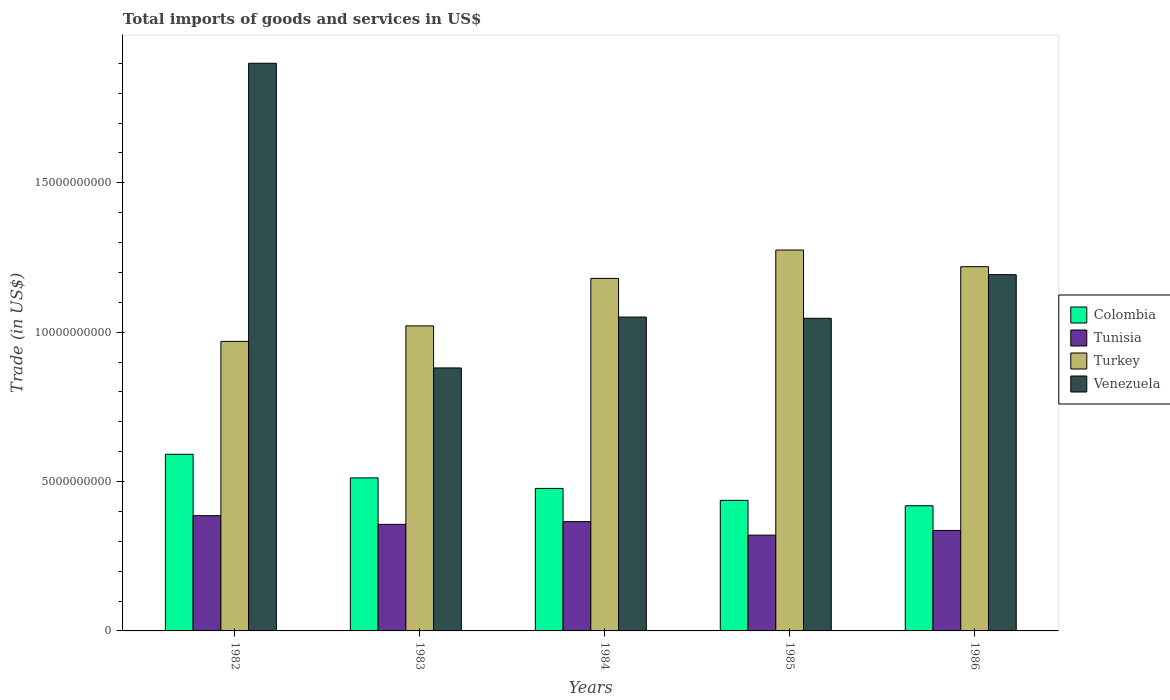How many groups of bars are there?
Your answer should be very brief. 5. Are the number of bars per tick equal to the number of legend labels?
Make the answer very short. Yes. Are the number of bars on each tick of the X-axis equal?
Make the answer very short. Yes. How many bars are there on the 5th tick from the left?
Offer a very short reply. 4. What is the total imports of goods and services in Colombia in 1984?
Provide a succinct answer. 4.77e+09. Across all years, what is the maximum total imports of goods and services in Venezuela?
Give a very brief answer. 1.90e+1. Across all years, what is the minimum total imports of goods and services in Colombia?
Your response must be concise. 4.19e+09. In which year was the total imports of goods and services in Tunisia maximum?
Make the answer very short. 1982. In which year was the total imports of goods and services in Colombia minimum?
Your response must be concise. 1986. What is the total total imports of goods and services in Turkey in the graph?
Ensure brevity in your answer.  5.67e+1. What is the difference between the total imports of goods and services in Venezuela in 1985 and that in 1986?
Your answer should be very brief. -1.46e+09. What is the difference between the total imports of goods and services in Turkey in 1985 and the total imports of goods and services in Colombia in 1984?
Offer a very short reply. 7.98e+09. What is the average total imports of goods and services in Tunisia per year?
Ensure brevity in your answer.  3.53e+09. In the year 1983, what is the difference between the total imports of goods and services in Venezuela and total imports of goods and services in Turkey?
Your answer should be compact. -1.41e+09. What is the ratio of the total imports of goods and services in Venezuela in 1982 to that in 1983?
Your answer should be compact. 2.16. Is the total imports of goods and services in Turkey in 1984 less than that in 1986?
Your response must be concise. Yes. Is the difference between the total imports of goods and services in Venezuela in 1982 and 1985 greater than the difference between the total imports of goods and services in Turkey in 1982 and 1985?
Your answer should be compact. Yes. What is the difference between the highest and the second highest total imports of goods and services in Turkey?
Keep it short and to the point. 5.58e+08. What is the difference between the highest and the lowest total imports of goods and services in Colombia?
Your answer should be very brief. 1.72e+09. Is the sum of the total imports of goods and services in Venezuela in 1983 and 1985 greater than the maximum total imports of goods and services in Colombia across all years?
Make the answer very short. Yes. Is it the case that in every year, the sum of the total imports of goods and services in Venezuela and total imports of goods and services in Tunisia is greater than the sum of total imports of goods and services in Colombia and total imports of goods and services in Turkey?
Make the answer very short. No. How many bars are there?
Your response must be concise. 20. Are all the bars in the graph horizontal?
Offer a terse response. No. How many years are there in the graph?
Give a very brief answer. 5. Are the values on the major ticks of Y-axis written in scientific E-notation?
Offer a very short reply. No. Does the graph contain any zero values?
Keep it short and to the point. No. Does the graph contain grids?
Your response must be concise. No. How many legend labels are there?
Ensure brevity in your answer.  4. How are the legend labels stacked?
Offer a very short reply. Vertical. What is the title of the graph?
Offer a very short reply. Total imports of goods and services in US$. Does "Latin America(all income levels)" appear as one of the legend labels in the graph?
Offer a terse response. No. What is the label or title of the Y-axis?
Give a very brief answer. Trade (in US$). What is the Trade (in US$) in Colombia in 1982?
Your answer should be very brief. 5.91e+09. What is the Trade (in US$) in Tunisia in 1982?
Offer a terse response. 3.86e+09. What is the Trade (in US$) in Turkey in 1982?
Offer a terse response. 9.69e+09. What is the Trade (in US$) in Venezuela in 1982?
Offer a terse response. 1.90e+1. What is the Trade (in US$) of Colombia in 1983?
Keep it short and to the point. 5.12e+09. What is the Trade (in US$) in Tunisia in 1983?
Make the answer very short. 3.57e+09. What is the Trade (in US$) in Turkey in 1983?
Offer a very short reply. 1.02e+1. What is the Trade (in US$) of Venezuela in 1983?
Provide a short and direct response. 8.80e+09. What is the Trade (in US$) of Colombia in 1984?
Offer a terse response. 4.77e+09. What is the Trade (in US$) of Tunisia in 1984?
Give a very brief answer. 3.66e+09. What is the Trade (in US$) in Turkey in 1984?
Provide a short and direct response. 1.18e+1. What is the Trade (in US$) of Venezuela in 1984?
Offer a very short reply. 1.05e+1. What is the Trade (in US$) of Colombia in 1985?
Your answer should be very brief. 4.37e+09. What is the Trade (in US$) in Tunisia in 1985?
Your response must be concise. 3.21e+09. What is the Trade (in US$) of Turkey in 1985?
Make the answer very short. 1.28e+1. What is the Trade (in US$) of Venezuela in 1985?
Ensure brevity in your answer.  1.05e+1. What is the Trade (in US$) in Colombia in 1986?
Provide a short and direct response. 4.19e+09. What is the Trade (in US$) in Tunisia in 1986?
Provide a short and direct response. 3.36e+09. What is the Trade (in US$) in Turkey in 1986?
Provide a short and direct response. 1.22e+1. What is the Trade (in US$) in Venezuela in 1986?
Provide a succinct answer. 1.19e+1. Across all years, what is the maximum Trade (in US$) in Colombia?
Make the answer very short. 5.91e+09. Across all years, what is the maximum Trade (in US$) in Tunisia?
Keep it short and to the point. 3.86e+09. Across all years, what is the maximum Trade (in US$) of Turkey?
Offer a very short reply. 1.28e+1. Across all years, what is the maximum Trade (in US$) of Venezuela?
Ensure brevity in your answer.  1.90e+1. Across all years, what is the minimum Trade (in US$) in Colombia?
Give a very brief answer. 4.19e+09. Across all years, what is the minimum Trade (in US$) in Tunisia?
Ensure brevity in your answer.  3.21e+09. Across all years, what is the minimum Trade (in US$) of Turkey?
Make the answer very short. 9.69e+09. Across all years, what is the minimum Trade (in US$) of Venezuela?
Offer a terse response. 8.80e+09. What is the total Trade (in US$) in Colombia in the graph?
Ensure brevity in your answer.  2.44e+1. What is the total Trade (in US$) in Tunisia in the graph?
Provide a succinct answer. 1.77e+1. What is the total Trade (in US$) of Turkey in the graph?
Your answer should be compact. 5.67e+1. What is the total Trade (in US$) of Venezuela in the graph?
Your response must be concise. 6.07e+1. What is the difference between the Trade (in US$) in Colombia in 1982 and that in 1983?
Provide a short and direct response. 7.91e+08. What is the difference between the Trade (in US$) of Tunisia in 1982 and that in 1983?
Provide a short and direct response. 2.91e+08. What is the difference between the Trade (in US$) of Turkey in 1982 and that in 1983?
Give a very brief answer. -5.20e+08. What is the difference between the Trade (in US$) of Venezuela in 1982 and that in 1983?
Provide a succinct answer. 1.02e+1. What is the difference between the Trade (in US$) in Colombia in 1982 and that in 1984?
Ensure brevity in your answer.  1.14e+09. What is the difference between the Trade (in US$) in Tunisia in 1982 and that in 1984?
Keep it short and to the point. 1.99e+08. What is the difference between the Trade (in US$) of Turkey in 1982 and that in 1984?
Make the answer very short. -2.11e+09. What is the difference between the Trade (in US$) in Venezuela in 1982 and that in 1984?
Give a very brief answer. 8.50e+09. What is the difference between the Trade (in US$) in Colombia in 1982 and that in 1985?
Provide a succinct answer. 1.54e+09. What is the difference between the Trade (in US$) of Tunisia in 1982 and that in 1985?
Offer a terse response. 6.51e+08. What is the difference between the Trade (in US$) of Turkey in 1982 and that in 1985?
Your response must be concise. -3.06e+09. What is the difference between the Trade (in US$) of Venezuela in 1982 and that in 1985?
Make the answer very short. 8.54e+09. What is the difference between the Trade (in US$) of Colombia in 1982 and that in 1986?
Give a very brief answer. 1.72e+09. What is the difference between the Trade (in US$) in Tunisia in 1982 and that in 1986?
Provide a succinct answer. 4.95e+08. What is the difference between the Trade (in US$) in Turkey in 1982 and that in 1986?
Provide a short and direct response. -2.50e+09. What is the difference between the Trade (in US$) in Venezuela in 1982 and that in 1986?
Ensure brevity in your answer.  7.08e+09. What is the difference between the Trade (in US$) of Colombia in 1983 and that in 1984?
Offer a very short reply. 3.52e+08. What is the difference between the Trade (in US$) in Tunisia in 1983 and that in 1984?
Give a very brief answer. -9.18e+07. What is the difference between the Trade (in US$) of Turkey in 1983 and that in 1984?
Offer a very short reply. -1.59e+09. What is the difference between the Trade (in US$) of Venezuela in 1983 and that in 1984?
Provide a short and direct response. -1.70e+09. What is the difference between the Trade (in US$) in Colombia in 1983 and that in 1985?
Offer a terse response. 7.52e+08. What is the difference between the Trade (in US$) of Tunisia in 1983 and that in 1985?
Offer a terse response. 3.60e+08. What is the difference between the Trade (in US$) in Turkey in 1983 and that in 1985?
Give a very brief answer. -2.54e+09. What is the difference between the Trade (in US$) in Venezuela in 1983 and that in 1985?
Ensure brevity in your answer.  -1.66e+09. What is the difference between the Trade (in US$) of Colombia in 1983 and that in 1986?
Offer a terse response. 9.32e+08. What is the difference between the Trade (in US$) of Tunisia in 1983 and that in 1986?
Your response must be concise. 2.03e+08. What is the difference between the Trade (in US$) in Turkey in 1983 and that in 1986?
Provide a succinct answer. -1.98e+09. What is the difference between the Trade (in US$) in Venezuela in 1983 and that in 1986?
Your answer should be compact. -3.12e+09. What is the difference between the Trade (in US$) of Colombia in 1984 and that in 1985?
Provide a short and direct response. 4.00e+08. What is the difference between the Trade (in US$) in Tunisia in 1984 and that in 1985?
Offer a very short reply. 4.52e+08. What is the difference between the Trade (in US$) in Turkey in 1984 and that in 1985?
Your answer should be very brief. -9.50e+08. What is the difference between the Trade (in US$) in Venezuela in 1984 and that in 1985?
Provide a short and direct response. 4.04e+07. What is the difference between the Trade (in US$) of Colombia in 1984 and that in 1986?
Make the answer very short. 5.80e+08. What is the difference between the Trade (in US$) of Tunisia in 1984 and that in 1986?
Provide a short and direct response. 2.95e+08. What is the difference between the Trade (in US$) in Turkey in 1984 and that in 1986?
Give a very brief answer. -3.92e+08. What is the difference between the Trade (in US$) in Venezuela in 1984 and that in 1986?
Provide a succinct answer. -1.42e+09. What is the difference between the Trade (in US$) of Colombia in 1985 and that in 1986?
Make the answer very short. 1.80e+08. What is the difference between the Trade (in US$) of Tunisia in 1985 and that in 1986?
Your answer should be very brief. -1.57e+08. What is the difference between the Trade (in US$) of Turkey in 1985 and that in 1986?
Provide a succinct answer. 5.58e+08. What is the difference between the Trade (in US$) of Venezuela in 1985 and that in 1986?
Ensure brevity in your answer.  -1.46e+09. What is the difference between the Trade (in US$) in Colombia in 1982 and the Trade (in US$) in Tunisia in 1983?
Your response must be concise. 2.35e+09. What is the difference between the Trade (in US$) of Colombia in 1982 and the Trade (in US$) of Turkey in 1983?
Offer a terse response. -4.30e+09. What is the difference between the Trade (in US$) of Colombia in 1982 and the Trade (in US$) of Venezuela in 1983?
Your answer should be very brief. -2.89e+09. What is the difference between the Trade (in US$) in Tunisia in 1982 and the Trade (in US$) in Turkey in 1983?
Ensure brevity in your answer.  -6.35e+09. What is the difference between the Trade (in US$) in Tunisia in 1982 and the Trade (in US$) in Venezuela in 1983?
Keep it short and to the point. -4.95e+09. What is the difference between the Trade (in US$) in Turkey in 1982 and the Trade (in US$) in Venezuela in 1983?
Your answer should be very brief. 8.88e+08. What is the difference between the Trade (in US$) of Colombia in 1982 and the Trade (in US$) of Tunisia in 1984?
Offer a very short reply. 2.25e+09. What is the difference between the Trade (in US$) of Colombia in 1982 and the Trade (in US$) of Turkey in 1984?
Offer a very short reply. -5.89e+09. What is the difference between the Trade (in US$) in Colombia in 1982 and the Trade (in US$) in Venezuela in 1984?
Give a very brief answer. -4.59e+09. What is the difference between the Trade (in US$) in Tunisia in 1982 and the Trade (in US$) in Turkey in 1984?
Keep it short and to the point. -7.94e+09. What is the difference between the Trade (in US$) of Tunisia in 1982 and the Trade (in US$) of Venezuela in 1984?
Make the answer very short. -6.65e+09. What is the difference between the Trade (in US$) in Turkey in 1982 and the Trade (in US$) in Venezuela in 1984?
Offer a very short reply. -8.14e+08. What is the difference between the Trade (in US$) in Colombia in 1982 and the Trade (in US$) in Tunisia in 1985?
Ensure brevity in your answer.  2.71e+09. What is the difference between the Trade (in US$) in Colombia in 1982 and the Trade (in US$) in Turkey in 1985?
Provide a succinct answer. -6.84e+09. What is the difference between the Trade (in US$) in Colombia in 1982 and the Trade (in US$) in Venezuela in 1985?
Ensure brevity in your answer.  -4.55e+09. What is the difference between the Trade (in US$) in Tunisia in 1982 and the Trade (in US$) in Turkey in 1985?
Give a very brief answer. -8.89e+09. What is the difference between the Trade (in US$) of Tunisia in 1982 and the Trade (in US$) of Venezuela in 1985?
Offer a very short reply. -6.61e+09. What is the difference between the Trade (in US$) in Turkey in 1982 and the Trade (in US$) in Venezuela in 1985?
Make the answer very short. -7.74e+08. What is the difference between the Trade (in US$) in Colombia in 1982 and the Trade (in US$) in Tunisia in 1986?
Make the answer very short. 2.55e+09. What is the difference between the Trade (in US$) in Colombia in 1982 and the Trade (in US$) in Turkey in 1986?
Offer a terse response. -6.28e+09. What is the difference between the Trade (in US$) of Colombia in 1982 and the Trade (in US$) of Venezuela in 1986?
Your answer should be compact. -6.01e+09. What is the difference between the Trade (in US$) in Tunisia in 1982 and the Trade (in US$) in Turkey in 1986?
Your response must be concise. -8.34e+09. What is the difference between the Trade (in US$) in Tunisia in 1982 and the Trade (in US$) in Venezuela in 1986?
Your answer should be very brief. -8.07e+09. What is the difference between the Trade (in US$) in Turkey in 1982 and the Trade (in US$) in Venezuela in 1986?
Make the answer very short. -2.23e+09. What is the difference between the Trade (in US$) in Colombia in 1983 and the Trade (in US$) in Tunisia in 1984?
Your response must be concise. 1.46e+09. What is the difference between the Trade (in US$) in Colombia in 1983 and the Trade (in US$) in Turkey in 1984?
Provide a succinct answer. -6.68e+09. What is the difference between the Trade (in US$) of Colombia in 1983 and the Trade (in US$) of Venezuela in 1984?
Make the answer very short. -5.38e+09. What is the difference between the Trade (in US$) of Tunisia in 1983 and the Trade (in US$) of Turkey in 1984?
Your response must be concise. -8.23e+09. What is the difference between the Trade (in US$) in Tunisia in 1983 and the Trade (in US$) in Venezuela in 1984?
Your answer should be very brief. -6.94e+09. What is the difference between the Trade (in US$) of Turkey in 1983 and the Trade (in US$) of Venezuela in 1984?
Provide a succinct answer. -2.94e+08. What is the difference between the Trade (in US$) in Colombia in 1983 and the Trade (in US$) in Tunisia in 1985?
Your answer should be compact. 1.92e+09. What is the difference between the Trade (in US$) of Colombia in 1983 and the Trade (in US$) of Turkey in 1985?
Your answer should be compact. -7.63e+09. What is the difference between the Trade (in US$) in Colombia in 1983 and the Trade (in US$) in Venezuela in 1985?
Make the answer very short. -5.34e+09. What is the difference between the Trade (in US$) of Tunisia in 1983 and the Trade (in US$) of Turkey in 1985?
Ensure brevity in your answer.  -9.18e+09. What is the difference between the Trade (in US$) in Tunisia in 1983 and the Trade (in US$) in Venezuela in 1985?
Your answer should be compact. -6.90e+09. What is the difference between the Trade (in US$) of Turkey in 1983 and the Trade (in US$) of Venezuela in 1985?
Offer a terse response. -2.54e+08. What is the difference between the Trade (in US$) of Colombia in 1983 and the Trade (in US$) of Tunisia in 1986?
Your response must be concise. 1.76e+09. What is the difference between the Trade (in US$) of Colombia in 1983 and the Trade (in US$) of Turkey in 1986?
Keep it short and to the point. -7.07e+09. What is the difference between the Trade (in US$) in Colombia in 1983 and the Trade (in US$) in Venezuela in 1986?
Give a very brief answer. -6.80e+09. What is the difference between the Trade (in US$) of Tunisia in 1983 and the Trade (in US$) of Turkey in 1986?
Ensure brevity in your answer.  -8.63e+09. What is the difference between the Trade (in US$) in Tunisia in 1983 and the Trade (in US$) in Venezuela in 1986?
Make the answer very short. -8.36e+09. What is the difference between the Trade (in US$) in Turkey in 1983 and the Trade (in US$) in Venezuela in 1986?
Offer a terse response. -1.71e+09. What is the difference between the Trade (in US$) in Colombia in 1984 and the Trade (in US$) in Tunisia in 1985?
Keep it short and to the point. 1.56e+09. What is the difference between the Trade (in US$) of Colombia in 1984 and the Trade (in US$) of Turkey in 1985?
Provide a succinct answer. -7.98e+09. What is the difference between the Trade (in US$) in Colombia in 1984 and the Trade (in US$) in Venezuela in 1985?
Offer a terse response. -5.70e+09. What is the difference between the Trade (in US$) of Tunisia in 1984 and the Trade (in US$) of Turkey in 1985?
Offer a terse response. -9.09e+09. What is the difference between the Trade (in US$) of Tunisia in 1984 and the Trade (in US$) of Venezuela in 1985?
Ensure brevity in your answer.  -6.81e+09. What is the difference between the Trade (in US$) of Turkey in 1984 and the Trade (in US$) of Venezuela in 1985?
Keep it short and to the point. 1.34e+09. What is the difference between the Trade (in US$) of Colombia in 1984 and the Trade (in US$) of Tunisia in 1986?
Your response must be concise. 1.41e+09. What is the difference between the Trade (in US$) in Colombia in 1984 and the Trade (in US$) in Turkey in 1986?
Your response must be concise. -7.42e+09. What is the difference between the Trade (in US$) in Colombia in 1984 and the Trade (in US$) in Venezuela in 1986?
Ensure brevity in your answer.  -7.16e+09. What is the difference between the Trade (in US$) in Tunisia in 1984 and the Trade (in US$) in Turkey in 1986?
Ensure brevity in your answer.  -8.53e+09. What is the difference between the Trade (in US$) in Tunisia in 1984 and the Trade (in US$) in Venezuela in 1986?
Offer a very short reply. -8.27e+09. What is the difference between the Trade (in US$) in Turkey in 1984 and the Trade (in US$) in Venezuela in 1986?
Provide a succinct answer. -1.25e+08. What is the difference between the Trade (in US$) of Colombia in 1985 and the Trade (in US$) of Tunisia in 1986?
Your answer should be very brief. 1.01e+09. What is the difference between the Trade (in US$) in Colombia in 1985 and the Trade (in US$) in Turkey in 1986?
Your answer should be very brief. -7.82e+09. What is the difference between the Trade (in US$) of Colombia in 1985 and the Trade (in US$) of Venezuela in 1986?
Your response must be concise. -7.56e+09. What is the difference between the Trade (in US$) in Tunisia in 1985 and the Trade (in US$) in Turkey in 1986?
Your answer should be compact. -8.99e+09. What is the difference between the Trade (in US$) of Tunisia in 1985 and the Trade (in US$) of Venezuela in 1986?
Your answer should be very brief. -8.72e+09. What is the difference between the Trade (in US$) in Turkey in 1985 and the Trade (in US$) in Venezuela in 1986?
Offer a very short reply. 8.25e+08. What is the average Trade (in US$) of Colombia per year?
Offer a terse response. 4.87e+09. What is the average Trade (in US$) in Tunisia per year?
Provide a short and direct response. 3.53e+09. What is the average Trade (in US$) in Turkey per year?
Offer a very short reply. 1.13e+1. What is the average Trade (in US$) of Venezuela per year?
Keep it short and to the point. 1.21e+1. In the year 1982, what is the difference between the Trade (in US$) in Colombia and Trade (in US$) in Tunisia?
Offer a terse response. 2.06e+09. In the year 1982, what is the difference between the Trade (in US$) of Colombia and Trade (in US$) of Turkey?
Your response must be concise. -3.78e+09. In the year 1982, what is the difference between the Trade (in US$) in Colombia and Trade (in US$) in Venezuela?
Give a very brief answer. -1.31e+1. In the year 1982, what is the difference between the Trade (in US$) in Tunisia and Trade (in US$) in Turkey?
Give a very brief answer. -5.83e+09. In the year 1982, what is the difference between the Trade (in US$) in Tunisia and Trade (in US$) in Venezuela?
Offer a very short reply. -1.51e+1. In the year 1982, what is the difference between the Trade (in US$) of Turkey and Trade (in US$) of Venezuela?
Your answer should be very brief. -9.31e+09. In the year 1983, what is the difference between the Trade (in US$) of Colombia and Trade (in US$) of Tunisia?
Your response must be concise. 1.56e+09. In the year 1983, what is the difference between the Trade (in US$) of Colombia and Trade (in US$) of Turkey?
Your answer should be very brief. -5.09e+09. In the year 1983, what is the difference between the Trade (in US$) of Colombia and Trade (in US$) of Venezuela?
Provide a succinct answer. -3.68e+09. In the year 1983, what is the difference between the Trade (in US$) of Tunisia and Trade (in US$) of Turkey?
Ensure brevity in your answer.  -6.65e+09. In the year 1983, what is the difference between the Trade (in US$) in Tunisia and Trade (in US$) in Venezuela?
Make the answer very short. -5.24e+09. In the year 1983, what is the difference between the Trade (in US$) of Turkey and Trade (in US$) of Venezuela?
Your answer should be very brief. 1.41e+09. In the year 1984, what is the difference between the Trade (in US$) in Colombia and Trade (in US$) in Tunisia?
Offer a very short reply. 1.11e+09. In the year 1984, what is the difference between the Trade (in US$) of Colombia and Trade (in US$) of Turkey?
Provide a succinct answer. -7.03e+09. In the year 1984, what is the difference between the Trade (in US$) in Colombia and Trade (in US$) in Venezuela?
Offer a terse response. -5.74e+09. In the year 1984, what is the difference between the Trade (in US$) in Tunisia and Trade (in US$) in Turkey?
Provide a succinct answer. -8.14e+09. In the year 1984, what is the difference between the Trade (in US$) in Tunisia and Trade (in US$) in Venezuela?
Your answer should be compact. -6.85e+09. In the year 1984, what is the difference between the Trade (in US$) in Turkey and Trade (in US$) in Venezuela?
Your response must be concise. 1.30e+09. In the year 1985, what is the difference between the Trade (in US$) of Colombia and Trade (in US$) of Tunisia?
Your answer should be compact. 1.16e+09. In the year 1985, what is the difference between the Trade (in US$) of Colombia and Trade (in US$) of Turkey?
Your response must be concise. -8.38e+09. In the year 1985, what is the difference between the Trade (in US$) of Colombia and Trade (in US$) of Venezuela?
Offer a terse response. -6.10e+09. In the year 1985, what is the difference between the Trade (in US$) of Tunisia and Trade (in US$) of Turkey?
Your response must be concise. -9.54e+09. In the year 1985, what is the difference between the Trade (in US$) of Tunisia and Trade (in US$) of Venezuela?
Your answer should be very brief. -7.26e+09. In the year 1985, what is the difference between the Trade (in US$) in Turkey and Trade (in US$) in Venezuela?
Provide a short and direct response. 2.29e+09. In the year 1986, what is the difference between the Trade (in US$) of Colombia and Trade (in US$) of Tunisia?
Your answer should be very brief. 8.27e+08. In the year 1986, what is the difference between the Trade (in US$) in Colombia and Trade (in US$) in Turkey?
Your answer should be very brief. -8.00e+09. In the year 1986, what is the difference between the Trade (in US$) of Colombia and Trade (in US$) of Venezuela?
Make the answer very short. -7.74e+09. In the year 1986, what is the difference between the Trade (in US$) of Tunisia and Trade (in US$) of Turkey?
Your answer should be very brief. -8.83e+09. In the year 1986, what is the difference between the Trade (in US$) in Tunisia and Trade (in US$) in Venezuela?
Your answer should be compact. -8.56e+09. In the year 1986, what is the difference between the Trade (in US$) of Turkey and Trade (in US$) of Venezuela?
Provide a succinct answer. 2.67e+08. What is the ratio of the Trade (in US$) of Colombia in 1982 to that in 1983?
Ensure brevity in your answer.  1.15. What is the ratio of the Trade (in US$) of Tunisia in 1982 to that in 1983?
Provide a succinct answer. 1.08. What is the ratio of the Trade (in US$) in Turkey in 1982 to that in 1983?
Make the answer very short. 0.95. What is the ratio of the Trade (in US$) of Venezuela in 1982 to that in 1983?
Provide a succinct answer. 2.16. What is the ratio of the Trade (in US$) in Colombia in 1982 to that in 1984?
Your response must be concise. 1.24. What is the ratio of the Trade (in US$) of Tunisia in 1982 to that in 1984?
Make the answer very short. 1.05. What is the ratio of the Trade (in US$) of Turkey in 1982 to that in 1984?
Offer a very short reply. 0.82. What is the ratio of the Trade (in US$) in Venezuela in 1982 to that in 1984?
Make the answer very short. 1.81. What is the ratio of the Trade (in US$) in Colombia in 1982 to that in 1985?
Your response must be concise. 1.35. What is the ratio of the Trade (in US$) of Tunisia in 1982 to that in 1985?
Your response must be concise. 1.2. What is the ratio of the Trade (in US$) in Turkey in 1982 to that in 1985?
Ensure brevity in your answer.  0.76. What is the ratio of the Trade (in US$) in Venezuela in 1982 to that in 1985?
Ensure brevity in your answer.  1.82. What is the ratio of the Trade (in US$) of Colombia in 1982 to that in 1986?
Provide a succinct answer. 1.41. What is the ratio of the Trade (in US$) in Tunisia in 1982 to that in 1986?
Offer a very short reply. 1.15. What is the ratio of the Trade (in US$) in Turkey in 1982 to that in 1986?
Your response must be concise. 0.79. What is the ratio of the Trade (in US$) of Venezuela in 1982 to that in 1986?
Offer a terse response. 1.59. What is the ratio of the Trade (in US$) in Colombia in 1983 to that in 1984?
Your answer should be very brief. 1.07. What is the ratio of the Trade (in US$) of Tunisia in 1983 to that in 1984?
Your answer should be compact. 0.97. What is the ratio of the Trade (in US$) in Turkey in 1983 to that in 1984?
Ensure brevity in your answer.  0.87. What is the ratio of the Trade (in US$) in Venezuela in 1983 to that in 1984?
Keep it short and to the point. 0.84. What is the ratio of the Trade (in US$) in Colombia in 1983 to that in 1985?
Make the answer very short. 1.17. What is the ratio of the Trade (in US$) of Tunisia in 1983 to that in 1985?
Provide a succinct answer. 1.11. What is the ratio of the Trade (in US$) in Turkey in 1983 to that in 1985?
Make the answer very short. 0.8. What is the ratio of the Trade (in US$) in Venezuela in 1983 to that in 1985?
Provide a succinct answer. 0.84. What is the ratio of the Trade (in US$) in Colombia in 1983 to that in 1986?
Provide a succinct answer. 1.22. What is the ratio of the Trade (in US$) of Tunisia in 1983 to that in 1986?
Offer a terse response. 1.06. What is the ratio of the Trade (in US$) in Turkey in 1983 to that in 1986?
Make the answer very short. 0.84. What is the ratio of the Trade (in US$) of Venezuela in 1983 to that in 1986?
Keep it short and to the point. 0.74. What is the ratio of the Trade (in US$) in Colombia in 1984 to that in 1985?
Ensure brevity in your answer.  1.09. What is the ratio of the Trade (in US$) of Tunisia in 1984 to that in 1985?
Give a very brief answer. 1.14. What is the ratio of the Trade (in US$) in Turkey in 1984 to that in 1985?
Provide a succinct answer. 0.93. What is the ratio of the Trade (in US$) in Venezuela in 1984 to that in 1985?
Give a very brief answer. 1. What is the ratio of the Trade (in US$) in Colombia in 1984 to that in 1986?
Keep it short and to the point. 1.14. What is the ratio of the Trade (in US$) of Tunisia in 1984 to that in 1986?
Make the answer very short. 1.09. What is the ratio of the Trade (in US$) of Turkey in 1984 to that in 1986?
Your answer should be very brief. 0.97. What is the ratio of the Trade (in US$) in Venezuela in 1984 to that in 1986?
Provide a succinct answer. 0.88. What is the ratio of the Trade (in US$) in Colombia in 1985 to that in 1986?
Provide a short and direct response. 1.04. What is the ratio of the Trade (in US$) in Tunisia in 1985 to that in 1986?
Your response must be concise. 0.95. What is the ratio of the Trade (in US$) in Turkey in 1985 to that in 1986?
Your response must be concise. 1.05. What is the ratio of the Trade (in US$) of Venezuela in 1985 to that in 1986?
Keep it short and to the point. 0.88. What is the difference between the highest and the second highest Trade (in US$) in Colombia?
Give a very brief answer. 7.91e+08. What is the difference between the highest and the second highest Trade (in US$) of Tunisia?
Provide a short and direct response. 1.99e+08. What is the difference between the highest and the second highest Trade (in US$) in Turkey?
Keep it short and to the point. 5.58e+08. What is the difference between the highest and the second highest Trade (in US$) of Venezuela?
Give a very brief answer. 7.08e+09. What is the difference between the highest and the lowest Trade (in US$) of Colombia?
Make the answer very short. 1.72e+09. What is the difference between the highest and the lowest Trade (in US$) in Tunisia?
Give a very brief answer. 6.51e+08. What is the difference between the highest and the lowest Trade (in US$) of Turkey?
Give a very brief answer. 3.06e+09. What is the difference between the highest and the lowest Trade (in US$) in Venezuela?
Offer a terse response. 1.02e+1. 